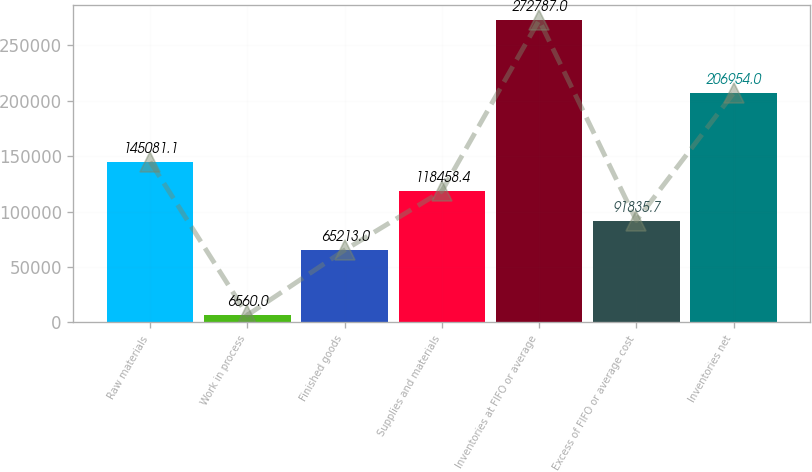<chart> <loc_0><loc_0><loc_500><loc_500><bar_chart><fcel>Raw materials<fcel>Work in process<fcel>Finished goods<fcel>Supplies and materials<fcel>Inventories at FIFO or average<fcel>Excess of FIFO or average cost<fcel>Inventories net<nl><fcel>145081<fcel>6560<fcel>65213<fcel>118458<fcel>272787<fcel>91835.7<fcel>206954<nl></chart> 